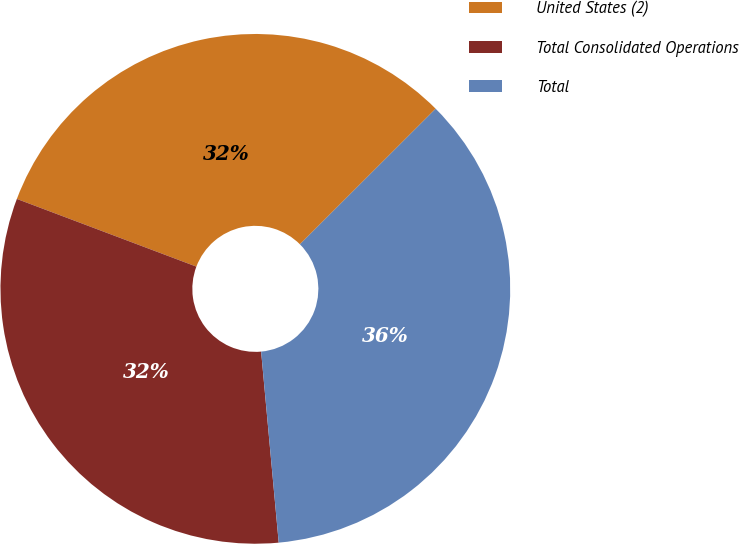Convert chart. <chart><loc_0><loc_0><loc_500><loc_500><pie_chart><fcel>United States (2)<fcel>Total Consolidated Operations<fcel>Total<nl><fcel>31.77%<fcel>32.2%<fcel>36.03%<nl></chart> 